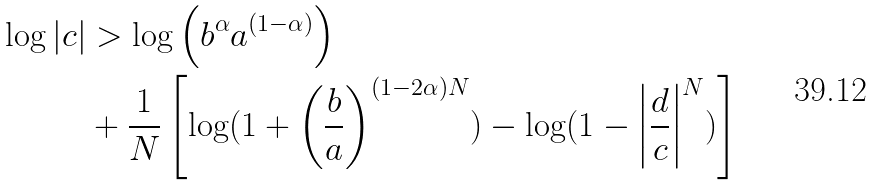<formula> <loc_0><loc_0><loc_500><loc_500>\log \left | c \right | & > \log \left ( b ^ { \alpha } a ^ { ( 1 - \alpha ) } \right ) \\ & + \frac { 1 } { N } \left [ \log ( 1 + \left ( \frac { b } { a } \right ) ^ { ( 1 - 2 \alpha ) N } ) - \log ( 1 - \left | \frac { d } { c } \right | ^ { N } ) \right ]</formula> 